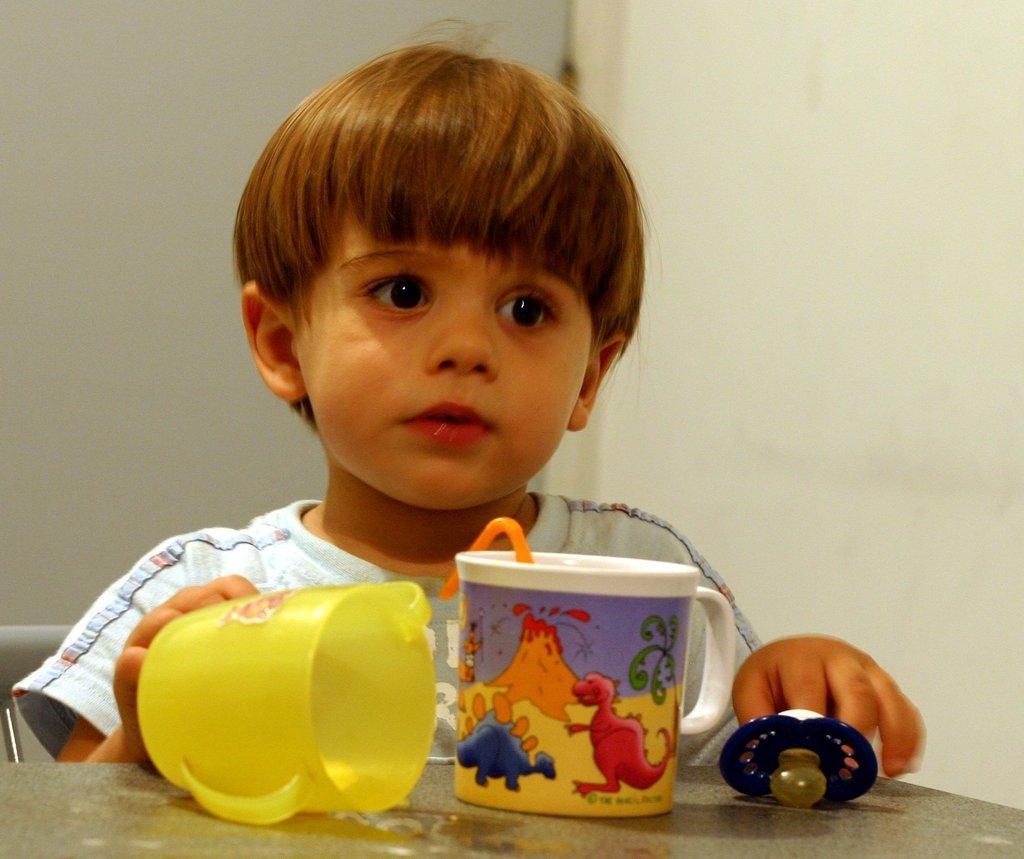Describe this image in one or two sentences. Here a kid is sitting on the chair. There is a cup,cap on the table. 